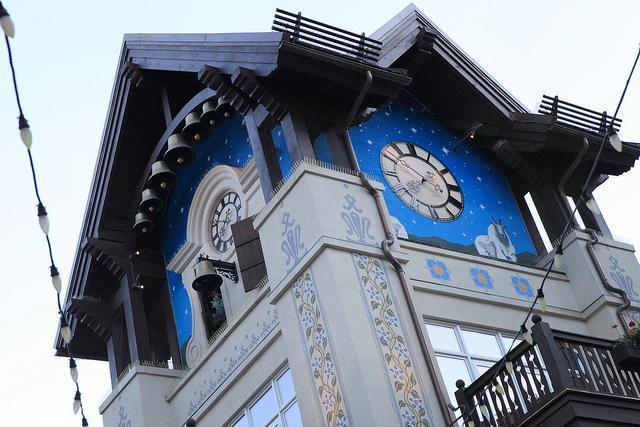How many clocks do you see?
Give a very brief answer. 2. 